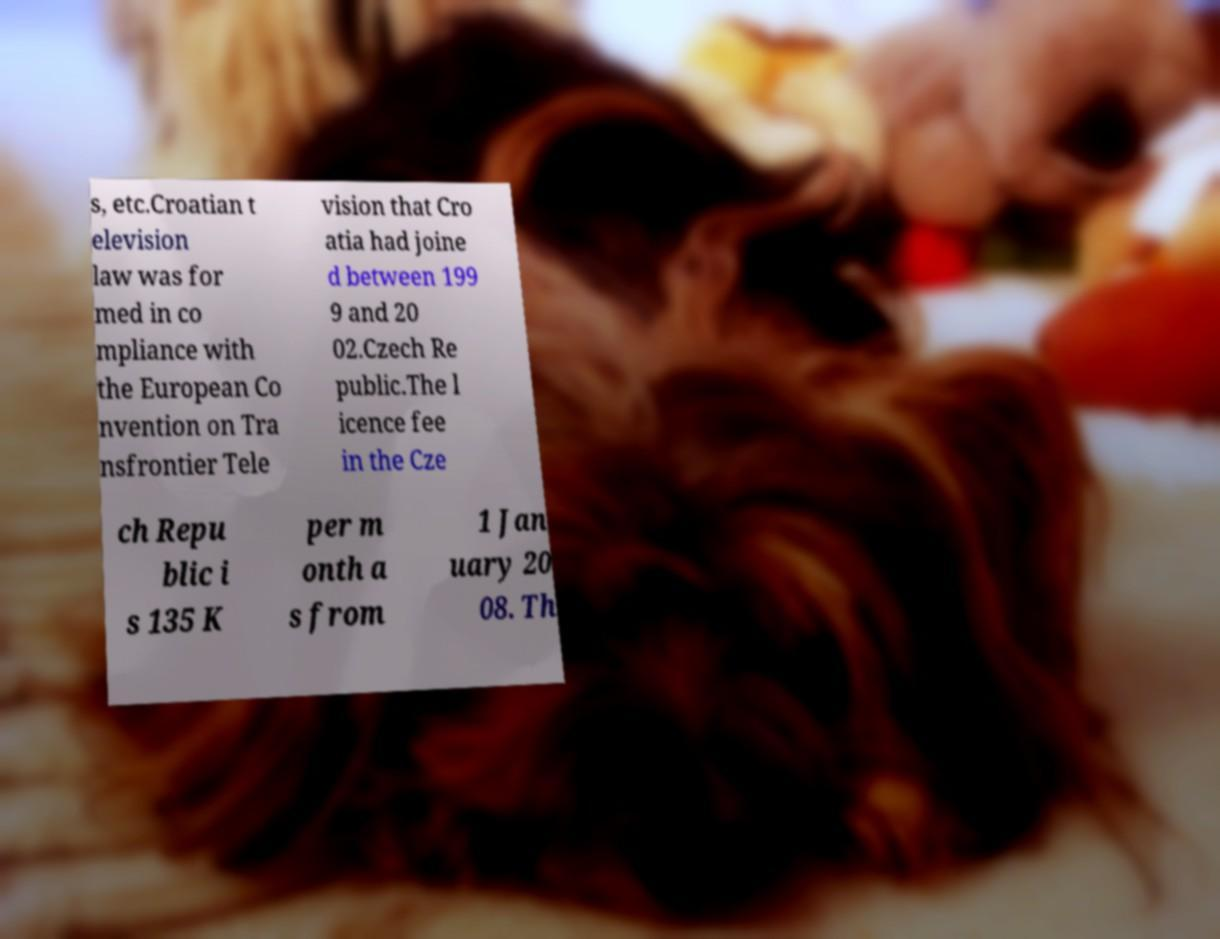Please read and relay the text visible in this image. What does it say? s, etc.Croatian t elevision law was for med in co mpliance with the European Co nvention on Tra nsfrontier Tele vision that Cro atia had joine d between 199 9 and 20 02.Czech Re public.The l icence fee in the Cze ch Repu blic i s 135 K per m onth a s from 1 Jan uary 20 08. Th 